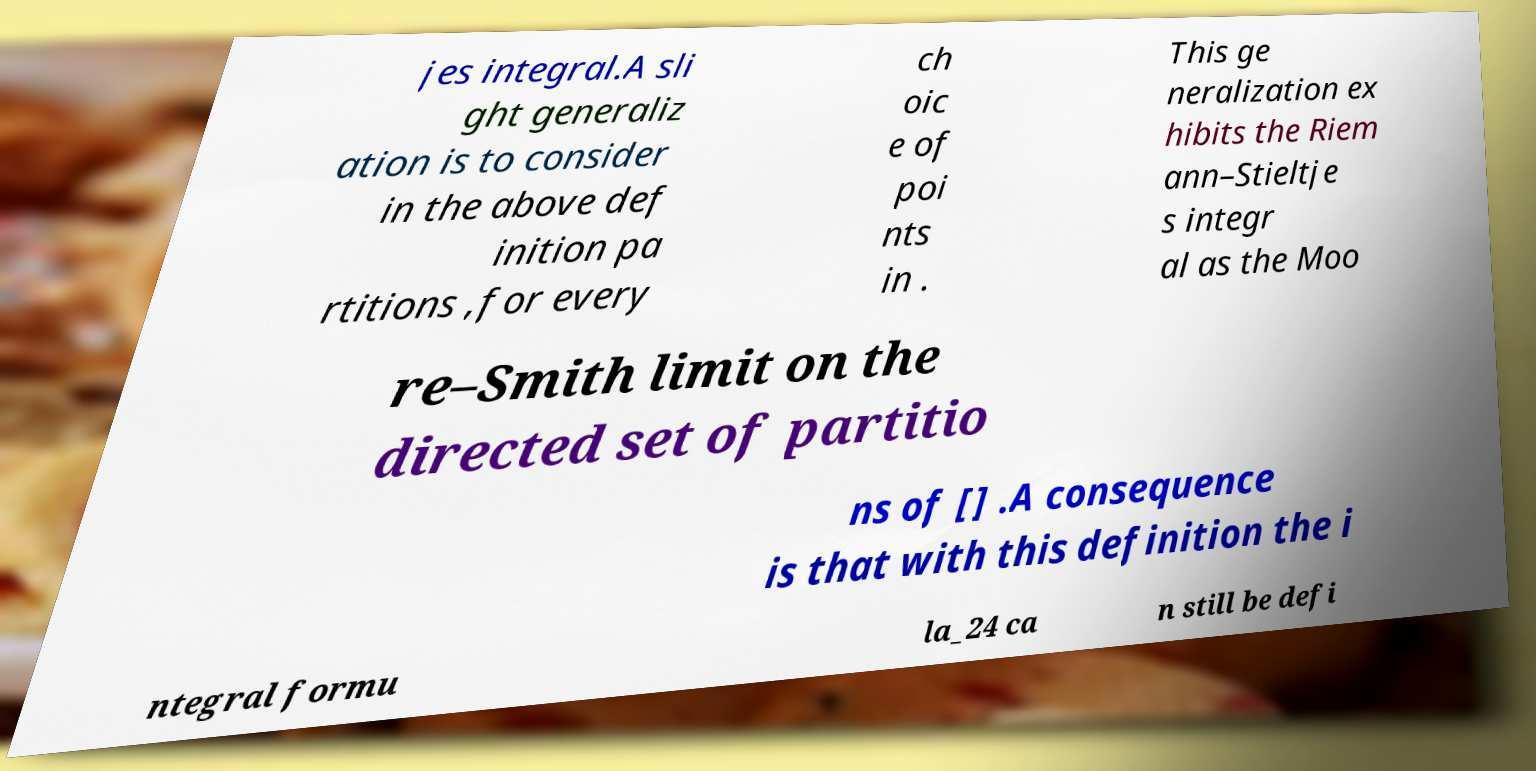There's text embedded in this image that I need extracted. Can you transcribe it verbatim? jes integral.A sli ght generaliz ation is to consider in the above def inition pa rtitions ,for every ch oic e of poi nts in . This ge neralization ex hibits the Riem ann–Stieltje s integr al as the Moo re–Smith limit on the directed set of partitio ns of [] .A consequence is that with this definition the i ntegral formu la_24 ca n still be defi 